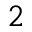<formula> <loc_0><loc_0><loc_500><loc_500>^ { 2 }</formula> 